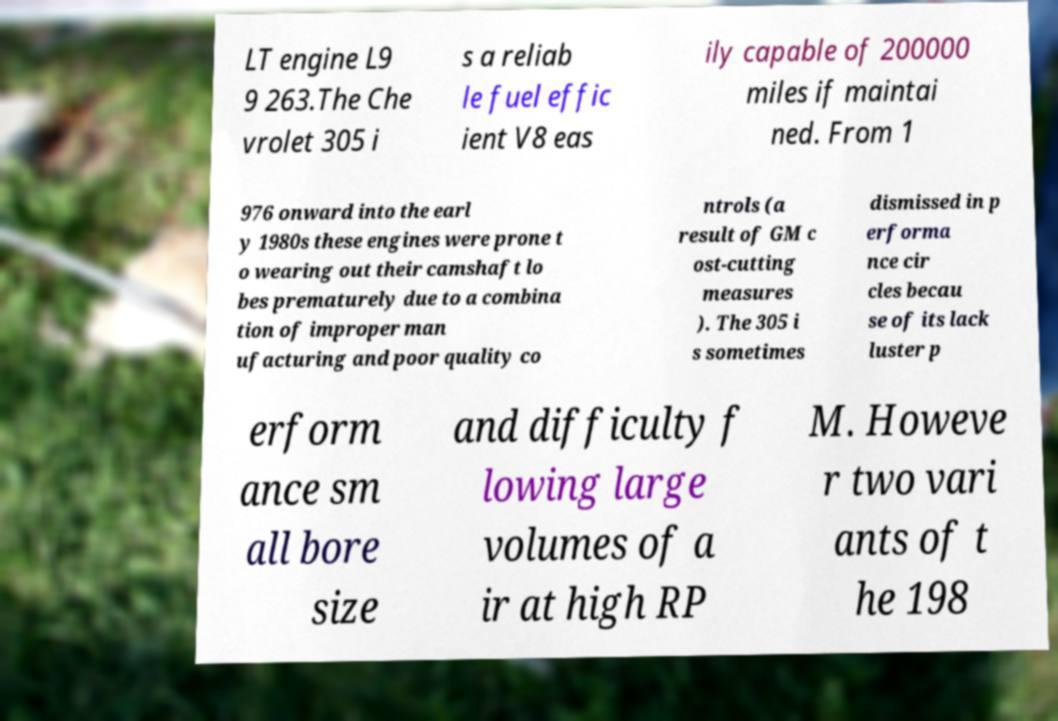What messages or text are displayed in this image? I need them in a readable, typed format. LT engine L9 9 263.The Che vrolet 305 i s a reliab le fuel effic ient V8 eas ily capable of 200000 miles if maintai ned. From 1 976 onward into the earl y 1980s these engines were prone t o wearing out their camshaft lo bes prematurely due to a combina tion of improper man ufacturing and poor quality co ntrols (a result of GM c ost-cutting measures ). The 305 i s sometimes dismissed in p erforma nce cir cles becau se of its lack luster p erform ance sm all bore size and difficulty f lowing large volumes of a ir at high RP M. Howeve r two vari ants of t he 198 